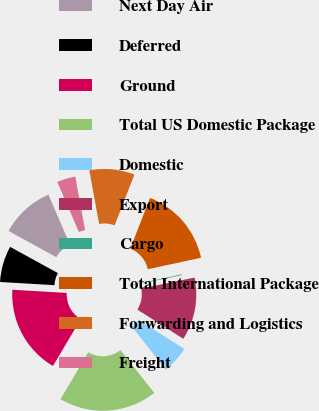<chart> <loc_0><loc_0><loc_500><loc_500><pie_chart><fcel>Next Day Air<fcel>Deferred<fcel>Ground<fcel>Total US Domestic Package<fcel>Domestic<fcel>Export<fcel>Cargo<fcel>Total International Package<fcel>Forwarding and Logistics<fcel>Freight<nl><fcel>10.52%<fcel>7.06%<fcel>17.42%<fcel>19.15%<fcel>5.34%<fcel>12.24%<fcel>0.16%<fcel>15.7%<fcel>8.79%<fcel>3.61%<nl></chart> 